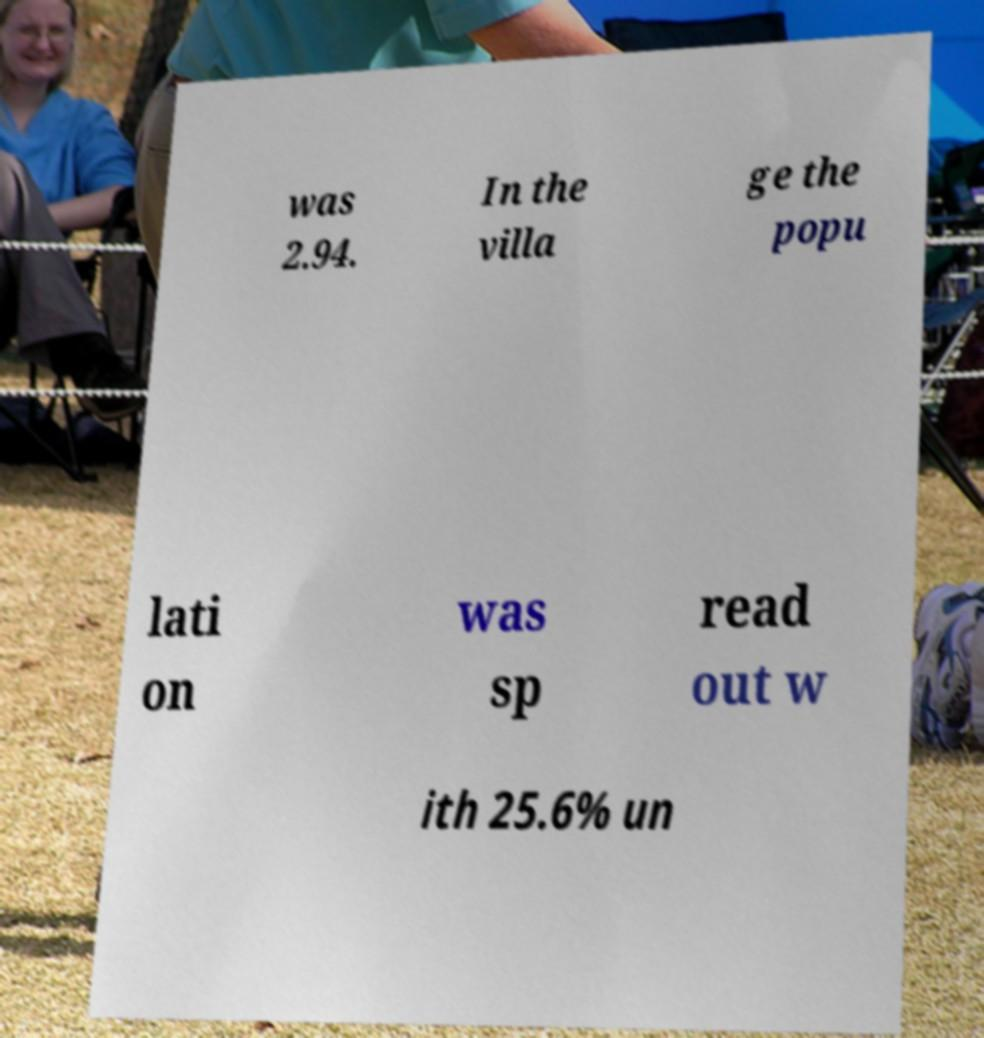Could you assist in decoding the text presented in this image and type it out clearly? was 2.94. In the villa ge the popu lati on was sp read out w ith 25.6% un 